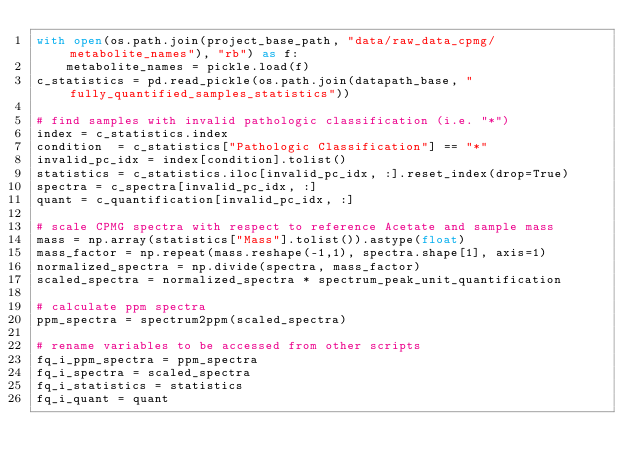<code> <loc_0><loc_0><loc_500><loc_500><_Python_>with open(os.path.join(project_base_path, "data/raw_data_cpmg/metabolite_names"), "rb") as f:
    metabolite_names = pickle.load(f)
c_statistics = pd.read_pickle(os.path.join(datapath_base, "fully_quantified_samples_statistics"))

# find samples with invalid pathologic classification (i.e. "*")
index = c_statistics.index
condition  = c_statistics["Pathologic Classification"] == "*"
invalid_pc_idx = index[condition].tolist()
statistics = c_statistics.iloc[invalid_pc_idx, :].reset_index(drop=True)
spectra = c_spectra[invalid_pc_idx, :]
quant = c_quantification[invalid_pc_idx, :]

# scale CPMG spectra with respect to reference Acetate and sample mass
mass = np.array(statistics["Mass"].tolist()).astype(float)
mass_factor = np.repeat(mass.reshape(-1,1), spectra.shape[1], axis=1)
normalized_spectra = np.divide(spectra, mass_factor)
scaled_spectra = normalized_spectra * spectrum_peak_unit_quantification

# calculate ppm spectra
ppm_spectra = spectrum2ppm(scaled_spectra)

# rename variables to be accessed from other scripts
fq_i_ppm_spectra = ppm_spectra
fq_i_spectra = scaled_spectra
fq_i_statistics = statistics
fq_i_quant = quant</code> 